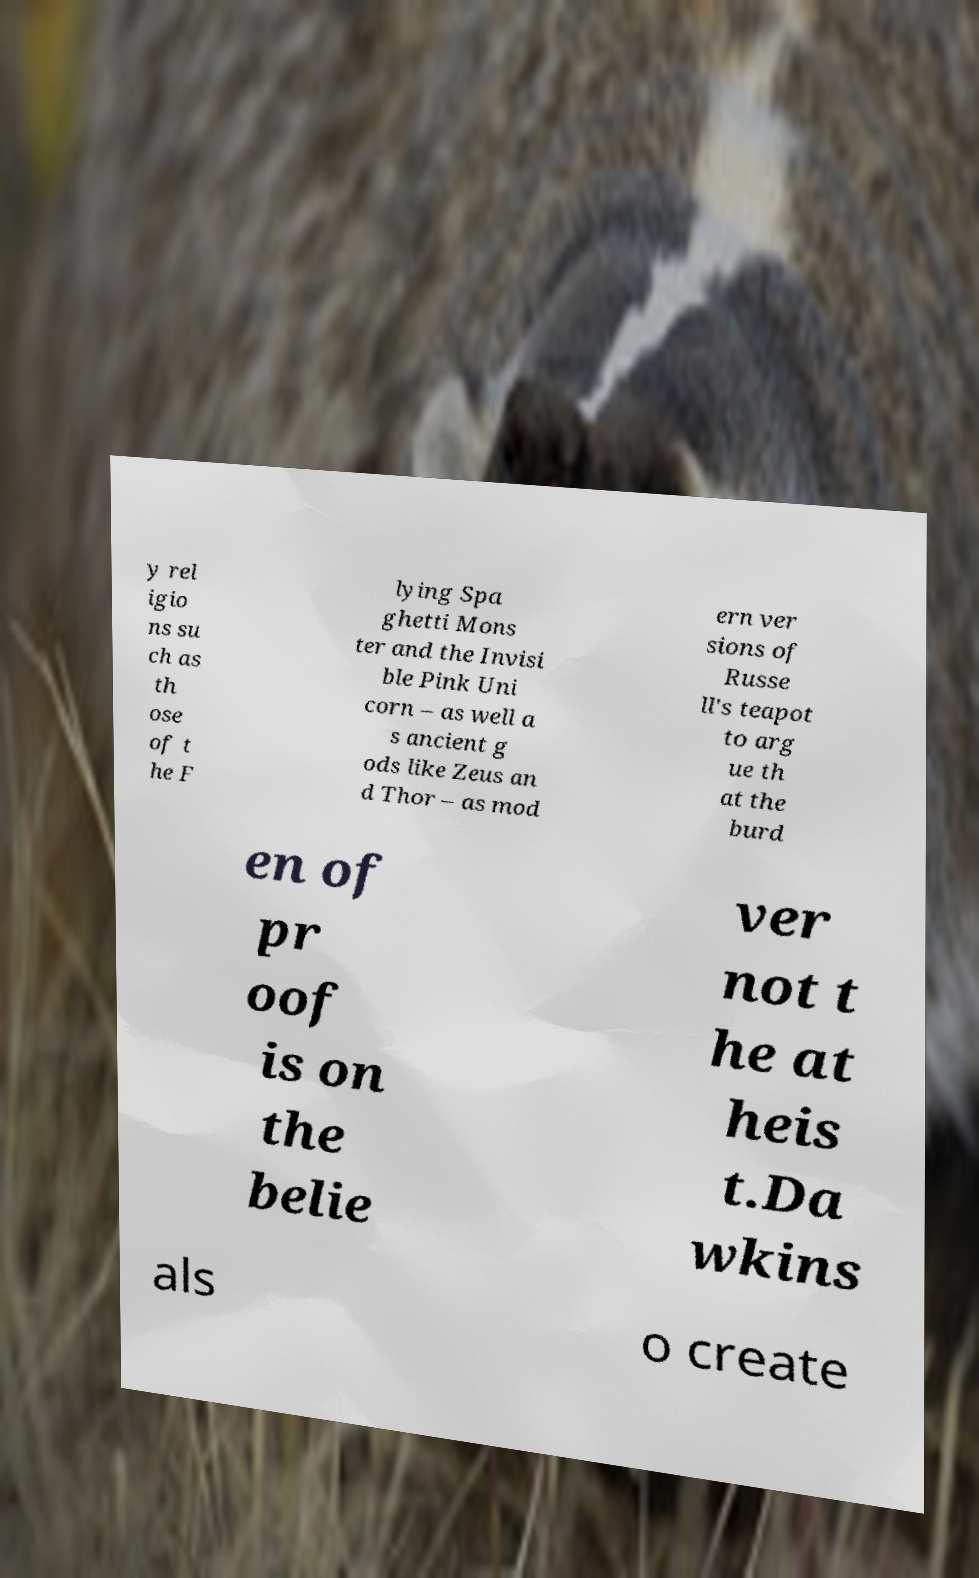Can you accurately transcribe the text from the provided image for me? y rel igio ns su ch as th ose of t he F lying Spa ghetti Mons ter and the Invisi ble Pink Uni corn – as well a s ancient g ods like Zeus an d Thor – as mod ern ver sions of Russe ll's teapot to arg ue th at the burd en of pr oof is on the belie ver not t he at heis t.Da wkins als o create 